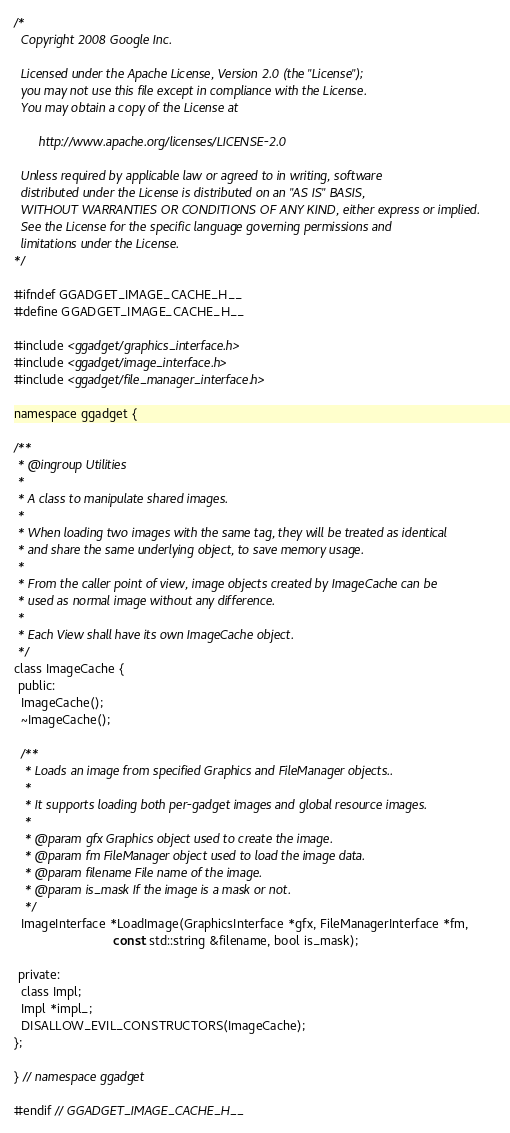<code> <loc_0><loc_0><loc_500><loc_500><_C_>/*
  Copyright 2008 Google Inc.

  Licensed under the Apache License, Version 2.0 (the "License");
  you may not use this file except in compliance with the License.
  You may obtain a copy of the License at

       http://www.apache.org/licenses/LICENSE-2.0

  Unless required by applicable law or agreed to in writing, software
  distributed under the License is distributed on an "AS IS" BASIS,
  WITHOUT WARRANTIES OR CONDITIONS OF ANY KIND, either express or implied.
  See the License for the specific language governing permissions and
  limitations under the License.
*/

#ifndef GGADGET_IMAGE_CACHE_H__
#define GGADGET_IMAGE_CACHE_H__

#include <ggadget/graphics_interface.h>
#include <ggadget/image_interface.h>
#include <ggadget/file_manager_interface.h>

namespace ggadget {

/**
 * @ingroup Utilities
 *
 * A class to manipulate shared images.
 *
 * When loading two images with the same tag, they will be treated as identical
 * and share the same underlying object, to save memory usage.
 *
 * From the caller point of view, image objects created by ImageCache can be
 * used as normal image without any difference.
 *
 * Each View shall have its own ImageCache object.
 */
class ImageCache {
 public:
  ImageCache();
  ~ImageCache();

  /**
   * Loads an image from specified Graphics and FileManager objects..
   *
   * It supports loading both per-gadget images and global resource images.
   *
   * @param gfx Graphics object used to create the image.
   * @param fm FileManager object used to load the image data.
   * @param filename File name of the image.
   * @param is_mask If the image is a mask or not.
   */
  ImageInterface *LoadImage(GraphicsInterface *gfx, FileManagerInterface *fm,
                            const std::string &filename, bool is_mask);

 private:
  class Impl;
  Impl *impl_;
  DISALLOW_EVIL_CONSTRUCTORS(ImageCache);
};

} // namespace ggadget

#endif // GGADGET_IMAGE_CACHE_H__
</code> 